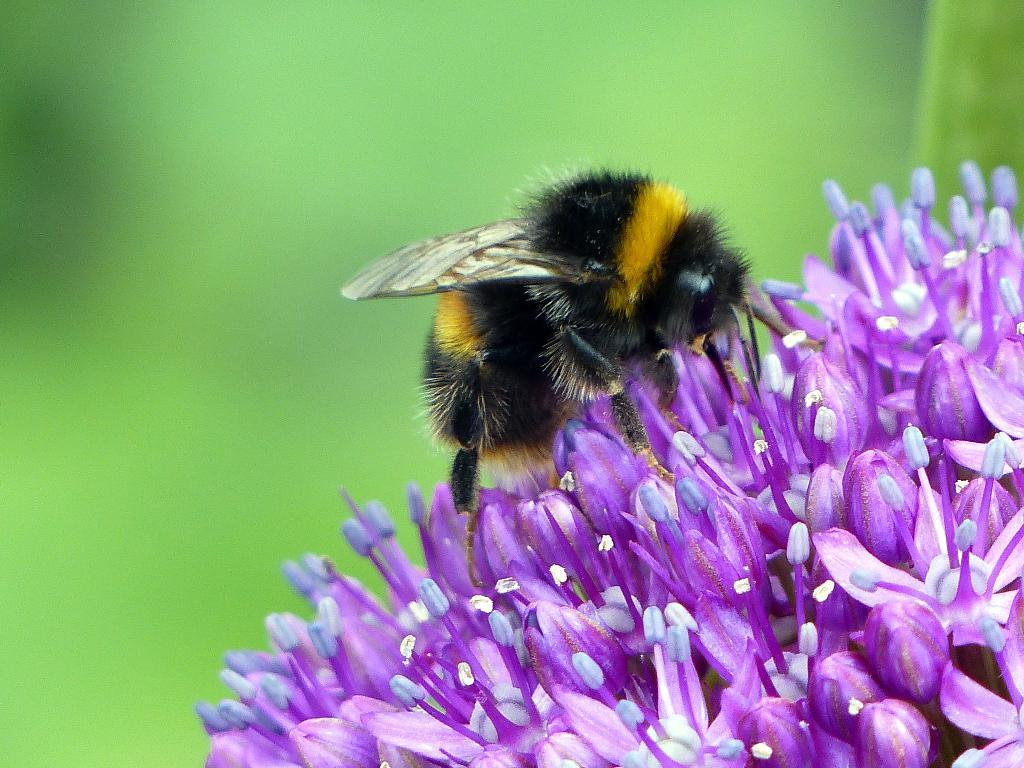What is present in the image? There are flowers in the image. Is there anything interacting with the flowers? Yes, there is a honey bee on the flowers. Can you describe the background of the image? The background of the image is blurry. What type of road can be seen in the image? There is no road present in the image; it features flowers and a honey bee. How does the yoke affect the behavior of the flowers in the image? There is no yoke present in the image, and therefore it cannot affect the behavior of the flowers. 